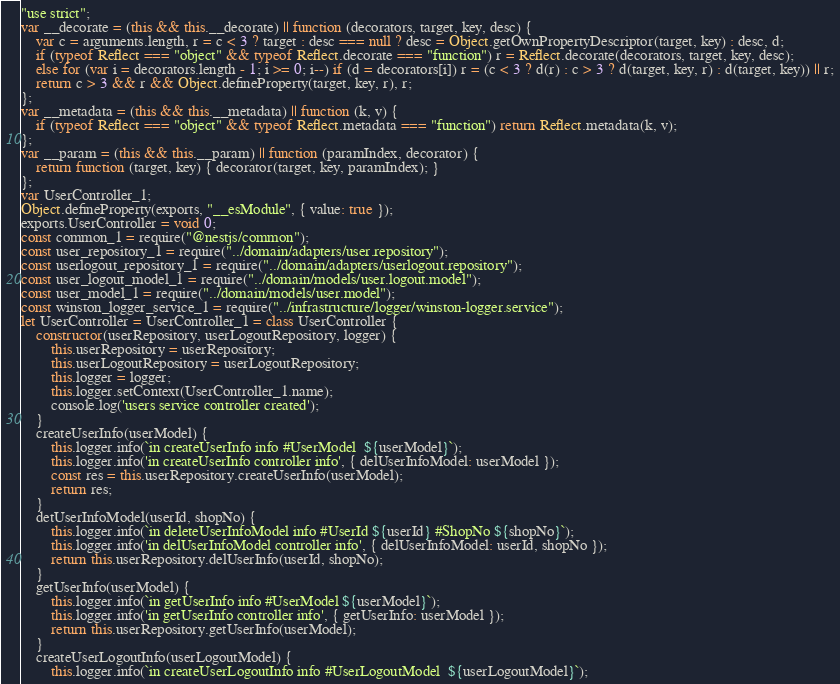Convert code to text. <code><loc_0><loc_0><loc_500><loc_500><_JavaScript_>"use strict";
var __decorate = (this && this.__decorate) || function (decorators, target, key, desc) {
    var c = arguments.length, r = c < 3 ? target : desc === null ? desc = Object.getOwnPropertyDescriptor(target, key) : desc, d;
    if (typeof Reflect === "object" && typeof Reflect.decorate === "function") r = Reflect.decorate(decorators, target, key, desc);
    else for (var i = decorators.length - 1; i >= 0; i--) if (d = decorators[i]) r = (c < 3 ? d(r) : c > 3 ? d(target, key, r) : d(target, key)) || r;
    return c > 3 && r && Object.defineProperty(target, key, r), r;
};
var __metadata = (this && this.__metadata) || function (k, v) {
    if (typeof Reflect === "object" && typeof Reflect.metadata === "function") return Reflect.metadata(k, v);
};
var __param = (this && this.__param) || function (paramIndex, decorator) {
    return function (target, key) { decorator(target, key, paramIndex); }
};
var UserController_1;
Object.defineProperty(exports, "__esModule", { value: true });
exports.UserController = void 0;
const common_1 = require("@nestjs/common");
const user_repository_1 = require("../domain/adapters/user.repository");
const userlogout_repository_1 = require("../domain/adapters/userlogout.repository");
const user_logout_model_1 = require("../domain/models/user.logout.model");
const user_model_1 = require("../domain/models/user.model");
const winston_logger_service_1 = require("../infrastructure/logger/winston-logger.service");
let UserController = UserController_1 = class UserController {
    constructor(userRepository, userLogoutRepository, logger) {
        this.userRepository = userRepository;
        this.userLogoutRepository = userLogoutRepository;
        this.logger = logger;
        this.logger.setContext(UserController_1.name);
        console.log('users service controller created');
    }
    createUserInfo(userModel) {
        this.logger.info(`in createUserInfo info #UserModel  ${userModel}`);
        this.logger.info('in createUserInfo controller info', { delUserInfoModel: userModel });
        const res = this.userRepository.createUserInfo(userModel);
        return res;
    }
    detUserInfoModel(userId, shopNo) {
        this.logger.info(`in deleteUserInfoModel info #UserId ${userId} #ShopNo ${shopNo}`);
        this.logger.info('in delUserInfoModel controller info', { delUserInfoModel: userId, shopNo });
        return this.userRepository.delUserInfo(userId, shopNo);
    }
    getUserInfo(userModel) {
        this.logger.info(`in getUserInfo info #UserModel ${userModel}`);
        this.logger.info('in getUserInfo controller info', { getUserInfo: userModel });
        return this.userRepository.getUserInfo(userModel);
    }
    createUserLogoutInfo(userLogoutModel) {
        this.logger.info(`in createUserLogoutInfo info #UserLogoutModel  ${userLogoutModel}`);</code> 